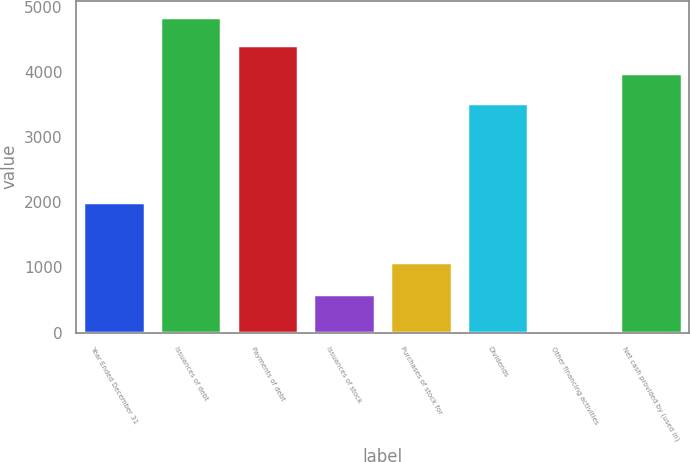Convert chart. <chart><loc_0><loc_0><loc_500><loc_500><bar_chart><fcel>Year Ended December 31<fcel>Issuances of debt<fcel>Payments of debt<fcel>Issuances of stock<fcel>Purchases of stock for<fcel>Dividends<fcel>Other financing activities<fcel>Net cash provided by (used in)<nl><fcel>2008<fcel>4850.6<fcel>4417.8<fcel>595<fcel>1079<fcel>3521<fcel>9<fcel>3985<nl></chart> 